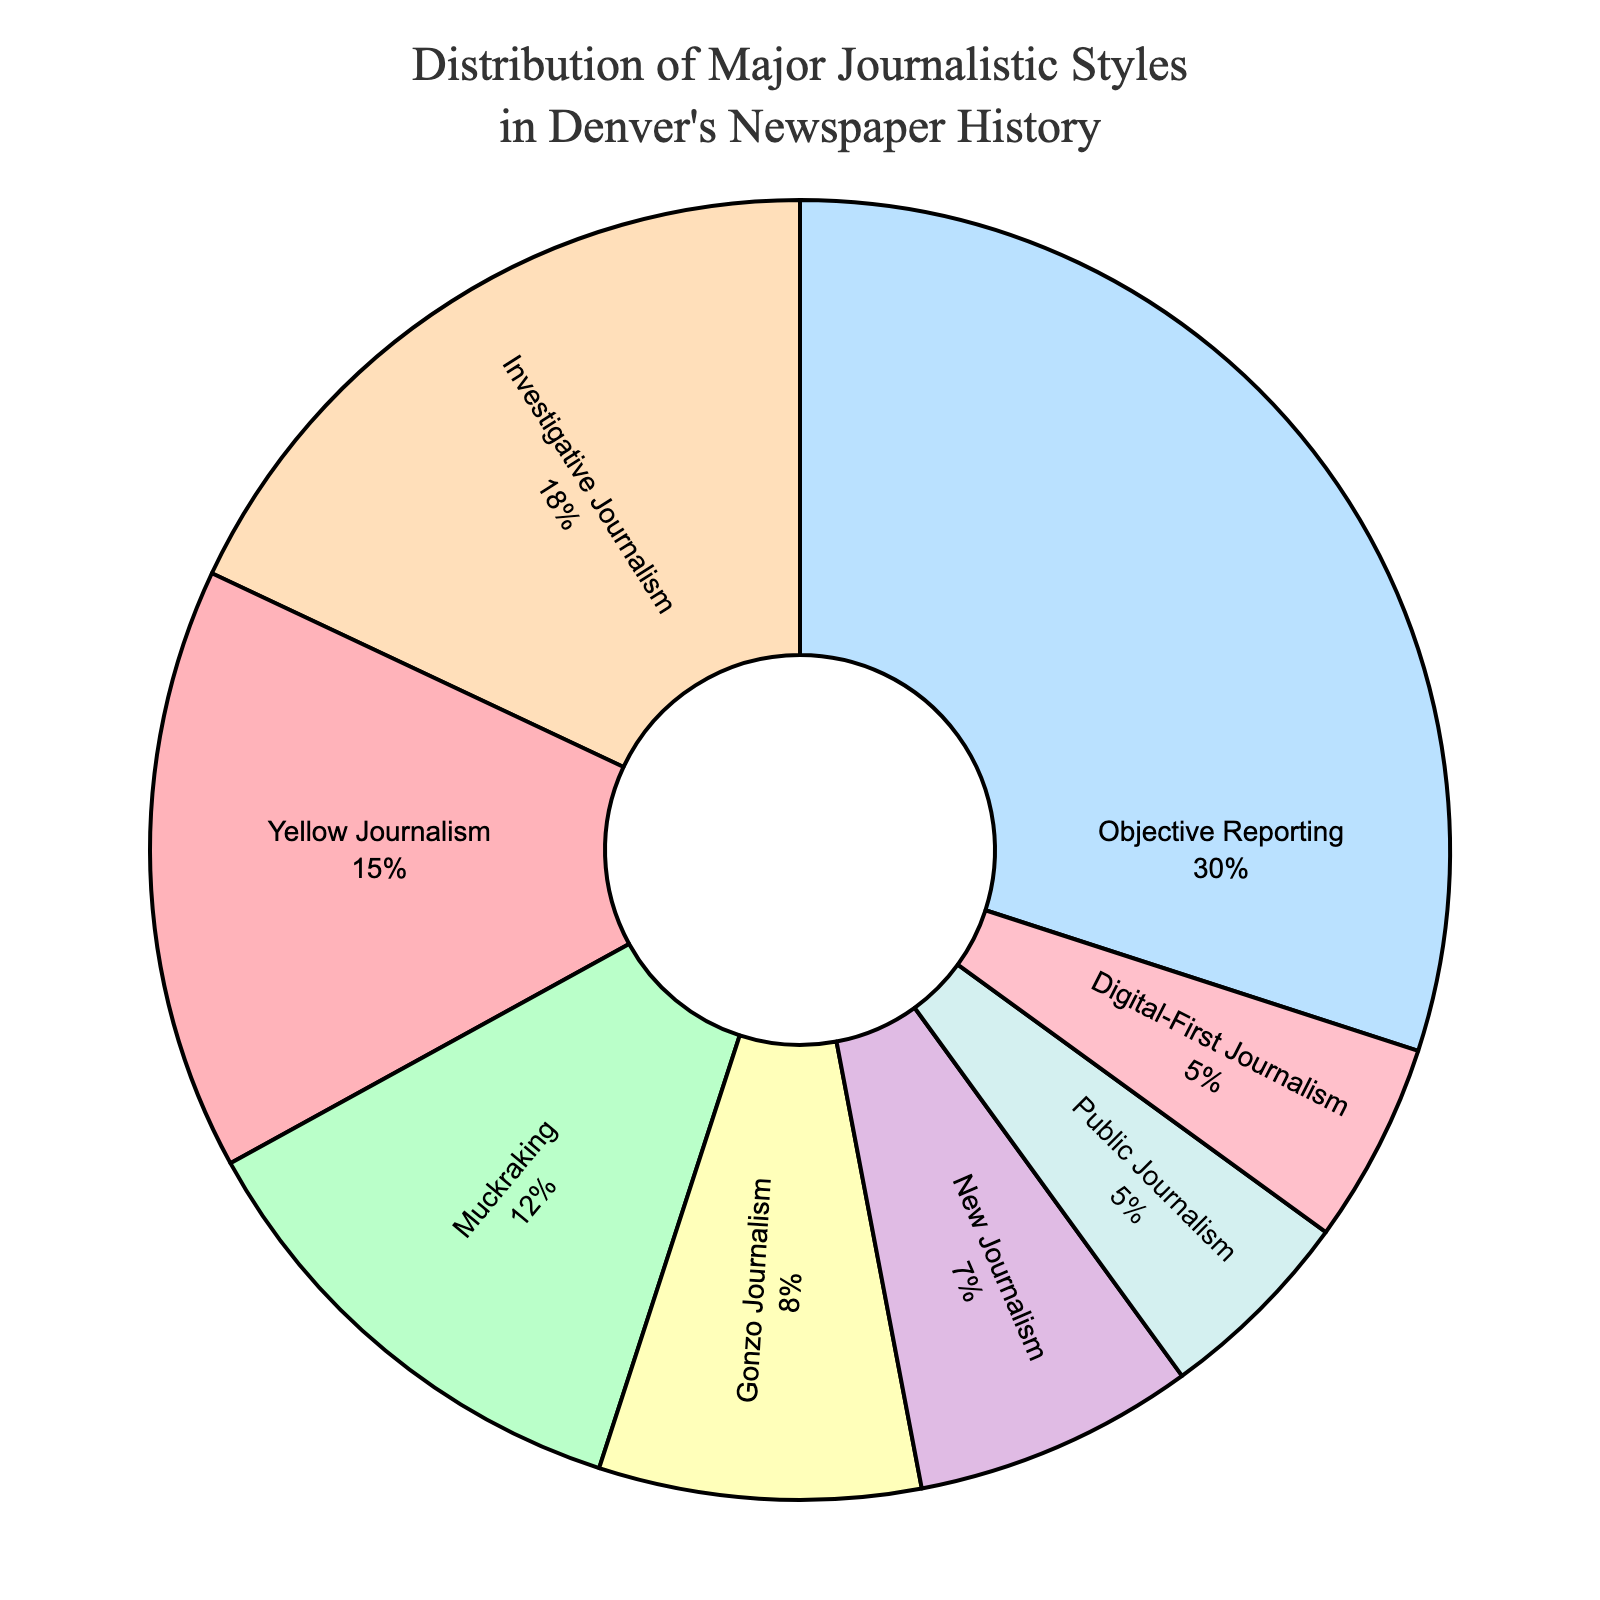Which journalistic style has the highest percentage in the pie chart? The journalistic style with the highest percentage will have the largest slice in the pie chart. In this case, "Objective Reporting" appears to be the largest slice.
Answer: Objective Reporting Which journalistic style has a smaller percentage, Muckraking or Gonzo Journalism? Compare the sizes of the slices for "Muckraking" and "Gonzo Journalism." "Muckraking" has a percentage of 12%, and "Gonzo Journalism" has a percentage of 8%. Therefore, "Gonzo Journalism" has a smaller percentage.
Answer: Gonzo Journalism What is the combined percentage of Investigative Journalism and Muckraking? Add the percentages of "Investigative Journalism" (18%) and "Muckraking" (12%). The combined percentage is 18% + 12% = 30%.
Answer: 30% Which journalistic styles each have a percentage of 5%? Look for slices labeled with 5%. "Public Journalism" and "Digital-First Journalism" each have a 5% slice.
Answer: Public Journalism and Digital-First Journalism Which style has a smaller slice: Yellow Journalism or New Journalism? Compare the sizes of the slices for "Yellow Journalism" and "New Journalism." "Yellow Journalism" has a percentage of 15%, and "New Journalism" has a percentage of 7%. Therefore, "New Journalism" has a smaller slice.
Answer: New Journalism What is the difference in percentage between the largest and smallest journalistic styles? The largest percentage is "Objective Reporting" at 30%, and the smallest percentage is shared by "Public Journalism" and "Digital-First Journalism" at 5% each. The difference is 30% - 5% = 25%.
Answer: 25% What is the total percentage of journalism styles that are less than 10% each? Add the percentages of styles that are less than 10%. "Gonzo Journalism" (8%), "New Journalism" (7%), "Public Journalism" (5%), and "Digital-First Journalism" (5%) give 8% + 7% + 5% + 5% = 25%.
Answer: 25% Of the styles with less than 10%, which style has the highest percentage? Compare the percentages of styles less than 10%: "Gonzo Journalism" (8%), "New Journalism" (7%), "Public Journalism" (5%), and "Digital-First Journalism" (5%). "Gonzo Journalism" has the highest percentage among them.
Answer: Gonzo Journalism If we combine the percentages of Yellow Journalism and Public Journalism, do they exceed the percentage of Objective Reporting? Add the percentages of "Yellow Journalism" (15%) and "Public Journalism" (5%) which equals 20%. Compare that to "Objective Reporting" (30%). 20% does not exceed 30%.
Answer: No Which color is associated with New Journalism in the pie chart? Identify the color slice associated with "New Journalism." Based on the given color sequence, "New Journalism" is represented by the second-to-last color, which is pink-ish (FFC0CB).
Answer: Pink 